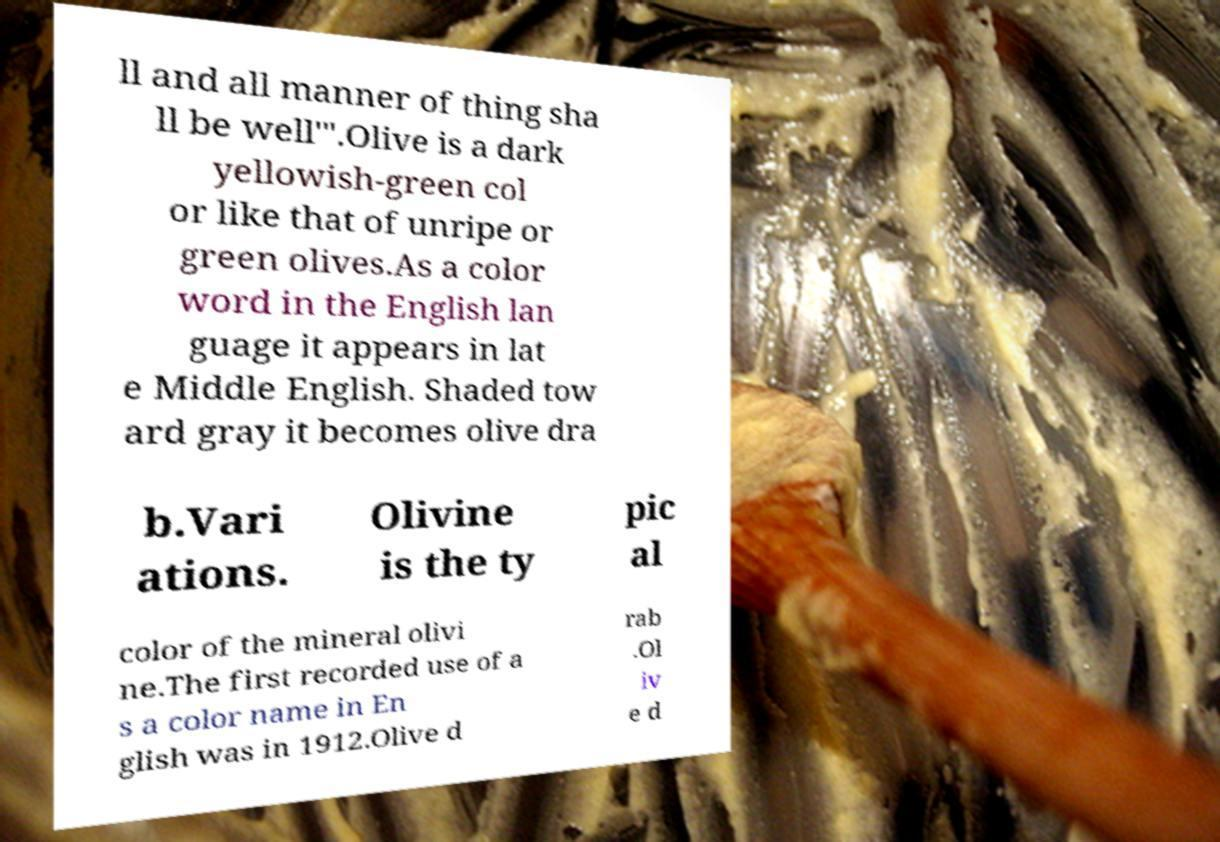For documentation purposes, I need the text within this image transcribed. Could you provide that? ll and all manner of thing sha ll be well'".Olive is a dark yellowish-green col or like that of unripe or green olives.As a color word in the English lan guage it appears in lat e Middle English. Shaded tow ard gray it becomes olive dra b.Vari ations. Olivine is the ty pic al color of the mineral olivi ne.The first recorded use of a s a color name in En glish was in 1912.Olive d rab .Ol iv e d 